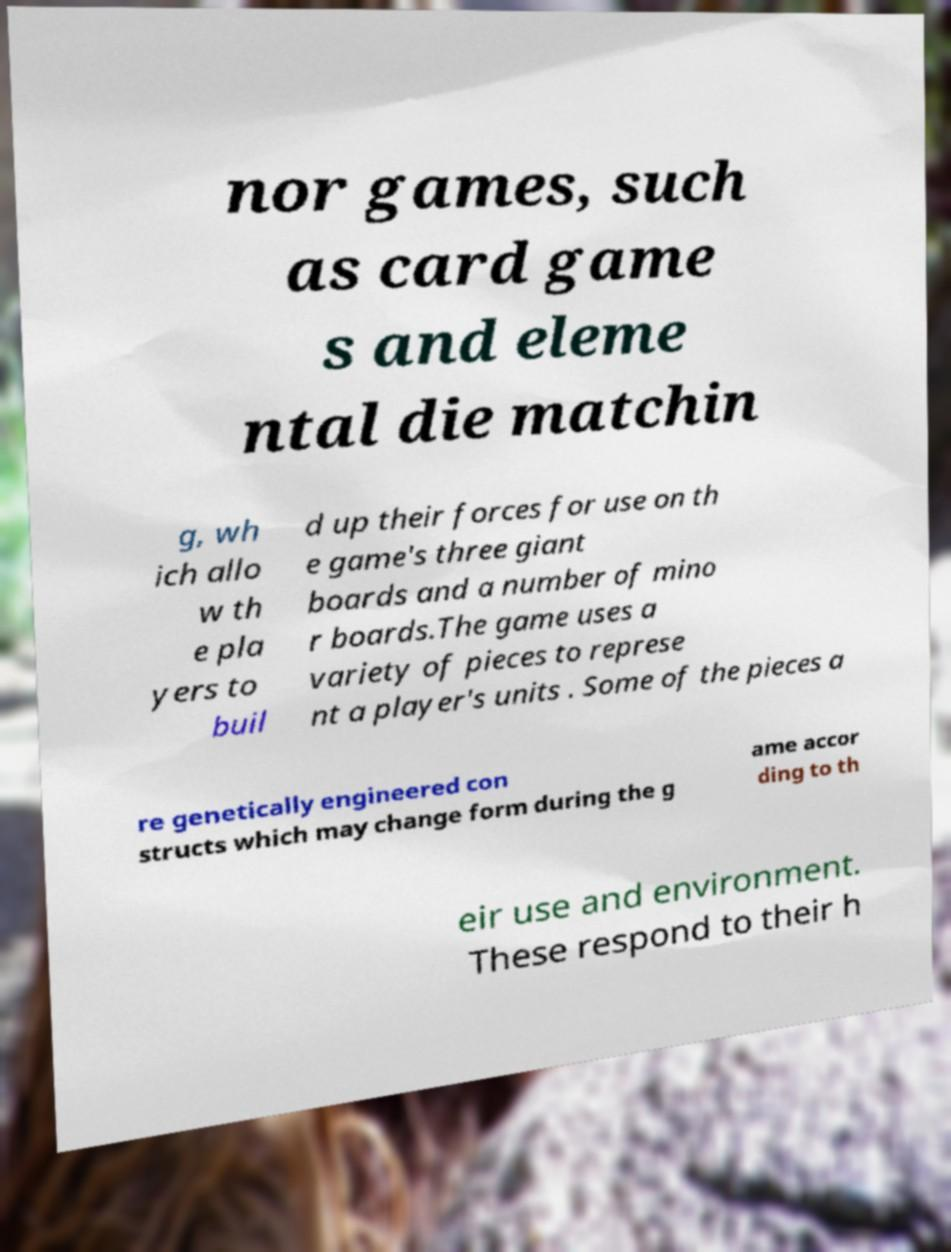Please identify and transcribe the text found in this image. nor games, such as card game s and eleme ntal die matchin g, wh ich allo w th e pla yers to buil d up their forces for use on th e game's three giant boards and a number of mino r boards.The game uses a variety of pieces to represe nt a player's units . Some of the pieces a re genetically engineered con structs which may change form during the g ame accor ding to th eir use and environment. These respond to their h 